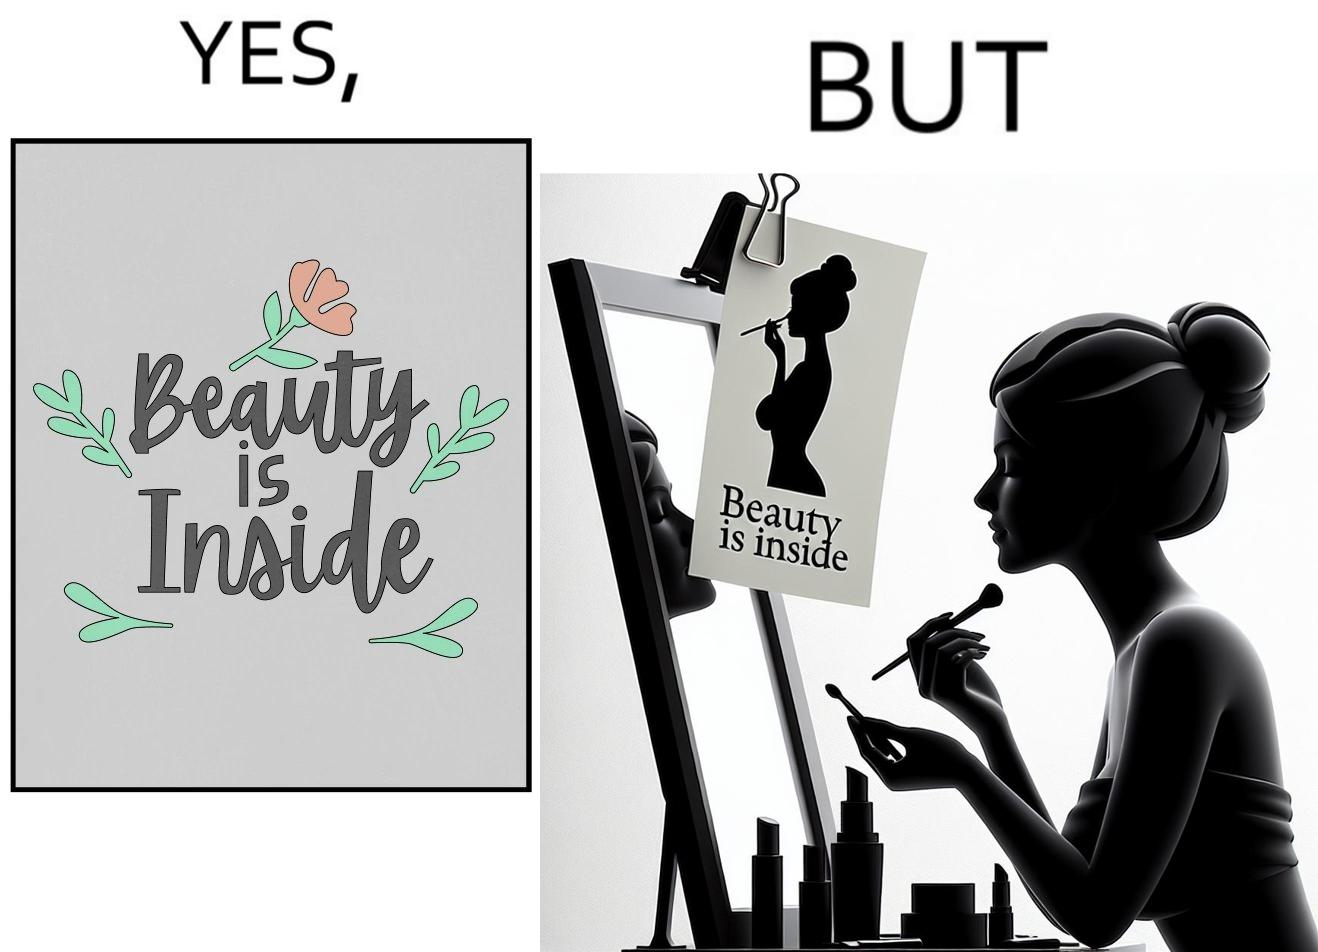Compare the left and right sides of this image. In the left part of the image: The image shows a text in beautiful font with flowers drawn around it. The text says "Beauty Is Inside". In the right part of the image: The image shows a woman applying makeup after shower by looking at herself in the dressing mirror. A piece of paper that says "Beauty is Inside" is clipped to the top of the mirror. 